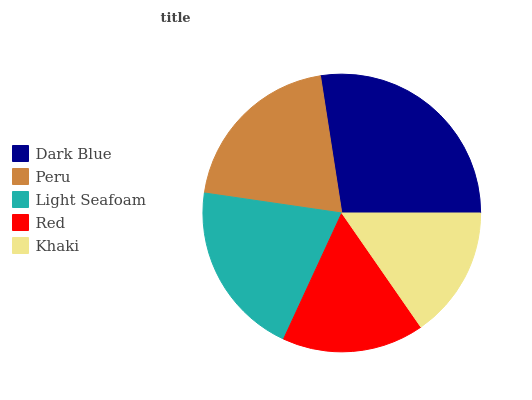Is Khaki the minimum?
Answer yes or no. Yes. Is Dark Blue the maximum?
Answer yes or no. Yes. Is Peru the minimum?
Answer yes or no. No. Is Peru the maximum?
Answer yes or no. No. Is Dark Blue greater than Peru?
Answer yes or no. Yes. Is Peru less than Dark Blue?
Answer yes or no. Yes. Is Peru greater than Dark Blue?
Answer yes or no. No. Is Dark Blue less than Peru?
Answer yes or no. No. Is Peru the high median?
Answer yes or no. Yes. Is Peru the low median?
Answer yes or no. Yes. Is Khaki the high median?
Answer yes or no. No. Is Red the low median?
Answer yes or no. No. 